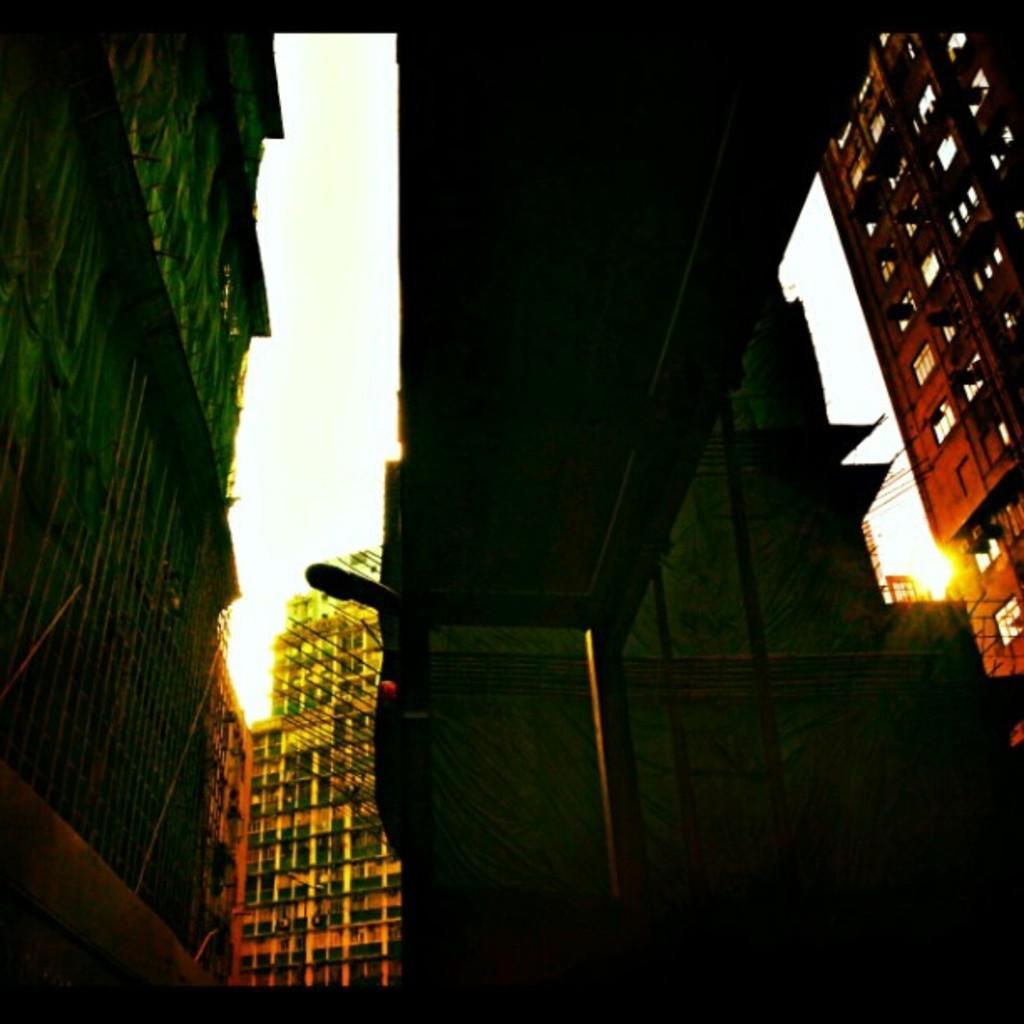Could you give a brief overview of what you see in this image? These are the buildings with windows. I think this is the flyover with pillars. 